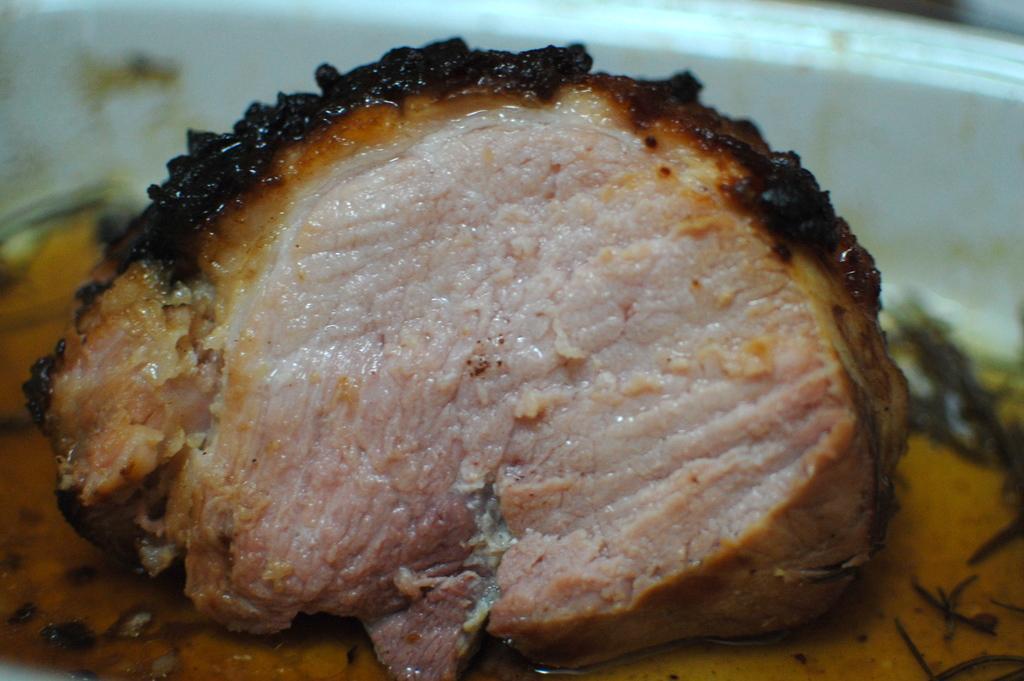Can you describe this image briefly? In the picture we can see a bowl with a slice of meat which is fried with a soup. 